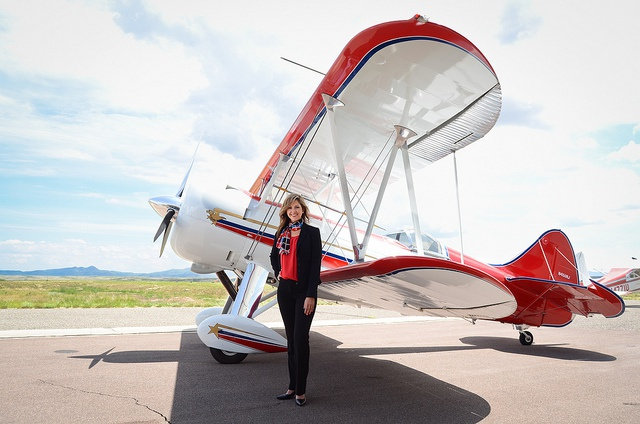Describe the objects in this image and their specific colors. I can see airplane in lightgray, darkgray, and brown tones, people in lightgray, black, gray, brown, and maroon tones, and airplane in lightgray, darkgray, brown, and lightpink tones in this image. 